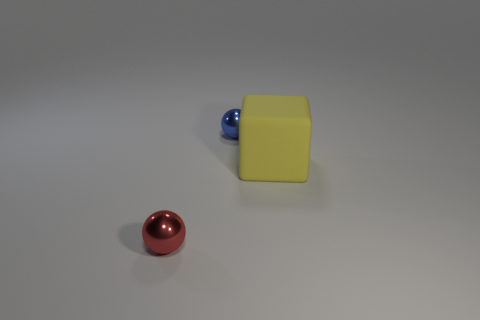Could there be a hidden meaning or symbolism in the colors and shapes selected for these objects? The selection of colors and shapes might not inherently possess symbolism. However, one could interpret them creatively; for instance, the primary colors (yellow and blue) and fundamental shapes (cube and spheres) might symbolize basic elements or ideas - the building blocks of more complex systems. 